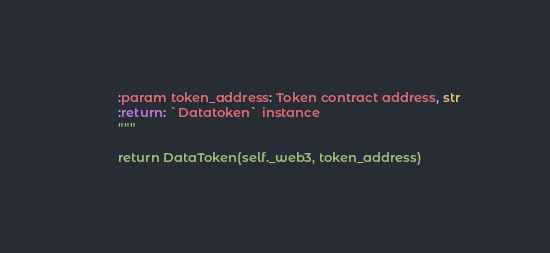Convert code to text. <code><loc_0><loc_0><loc_500><loc_500><_Python_>        :param token_address: Token contract address, str
        :return: `Datatoken` instance
        """

        return DataToken(self._web3, token_address)
</code> 